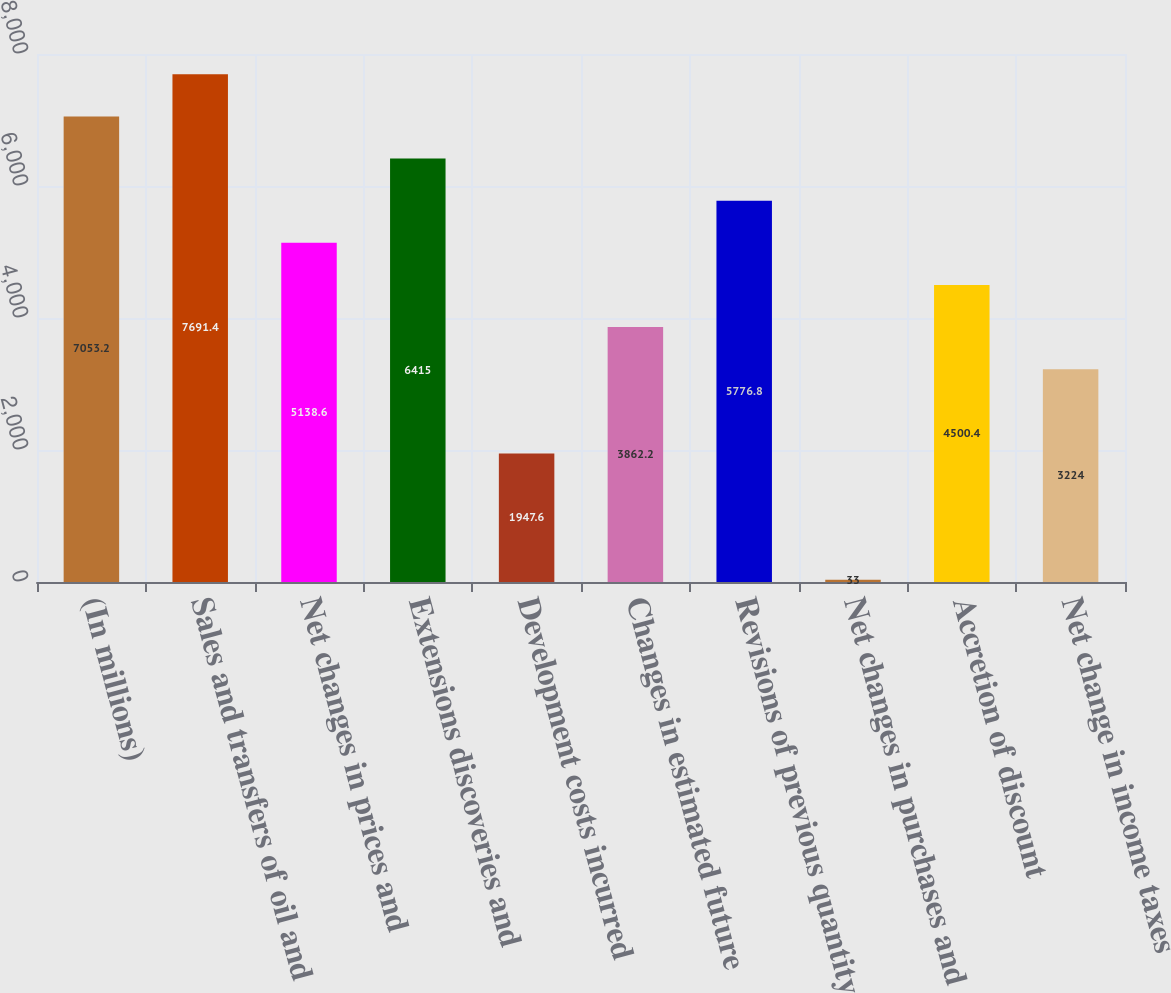Convert chart to OTSL. <chart><loc_0><loc_0><loc_500><loc_500><bar_chart><fcel>(In millions)<fcel>Sales and transfers of oil and<fcel>Net changes in prices and<fcel>Extensions discoveries and<fcel>Development costs incurred<fcel>Changes in estimated future<fcel>Revisions of previous quantity<fcel>Net changes in purchases and<fcel>Accretion of discount<fcel>Net change in income taxes<nl><fcel>7053.2<fcel>7691.4<fcel>5138.6<fcel>6415<fcel>1947.6<fcel>3862.2<fcel>5776.8<fcel>33<fcel>4500.4<fcel>3224<nl></chart> 